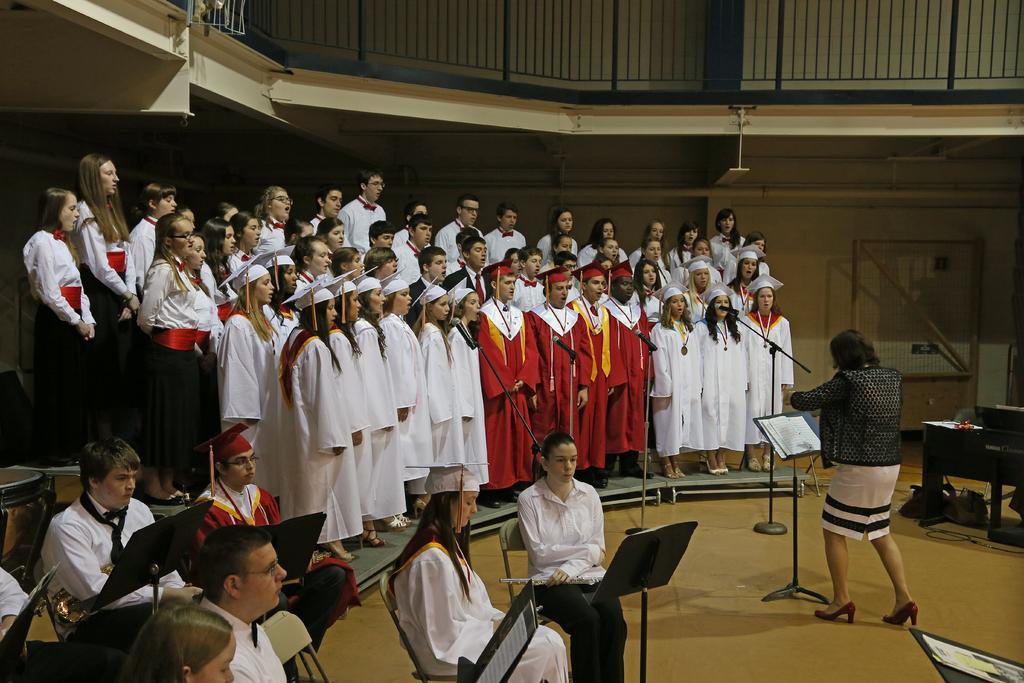Could you give a brief overview of what you see in this image? In the bottom left corner of the image few people are sitting. In the middle of the image few people are standing and we can see some microphones. Behind them we can see a wall. At the top of the image we can see fencing. In the bottom right corner of the image we can see some tables. 